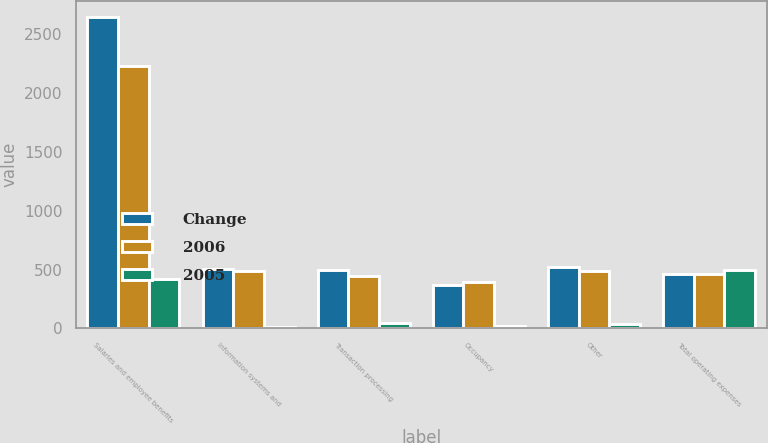Convert chart to OTSL. <chart><loc_0><loc_0><loc_500><loc_500><stacked_bar_chart><ecel><fcel>Salaries and employee benefits<fcel>Information systems and<fcel>Transaction processing<fcel>Occupancy<fcel>Other<fcel>Total operating expenses<nl><fcel>Change<fcel>2652<fcel>501<fcel>496<fcel>373<fcel>518<fcel>466.5<nl><fcel>2006<fcel>2231<fcel>486<fcel>449<fcel>391<fcel>484<fcel>466.5<nl><fcel>2005<fcel>421<fcel>15<fcel>47<fcel>18<fcel>34<fcel>499<nl></chart> 